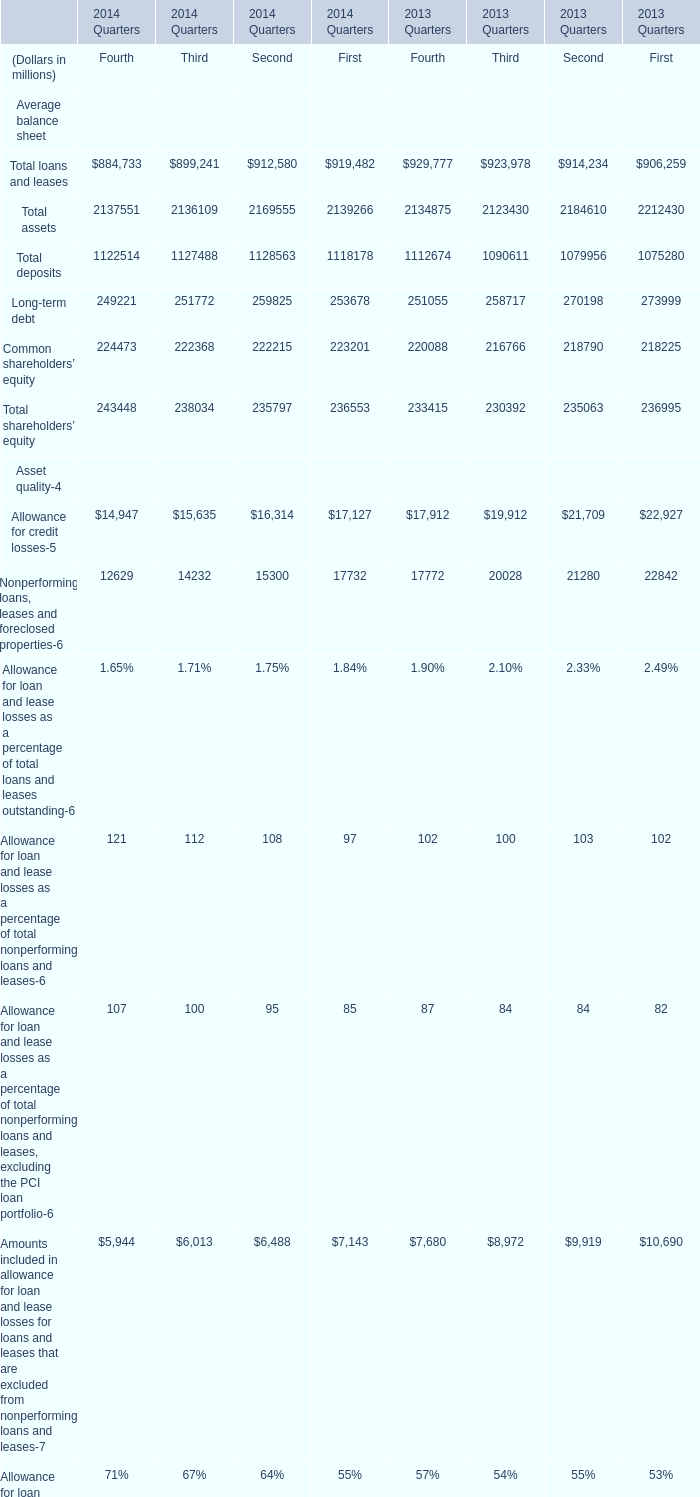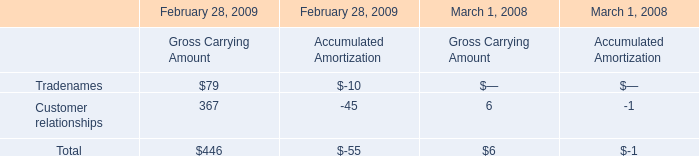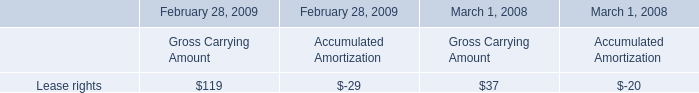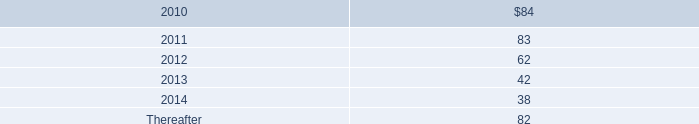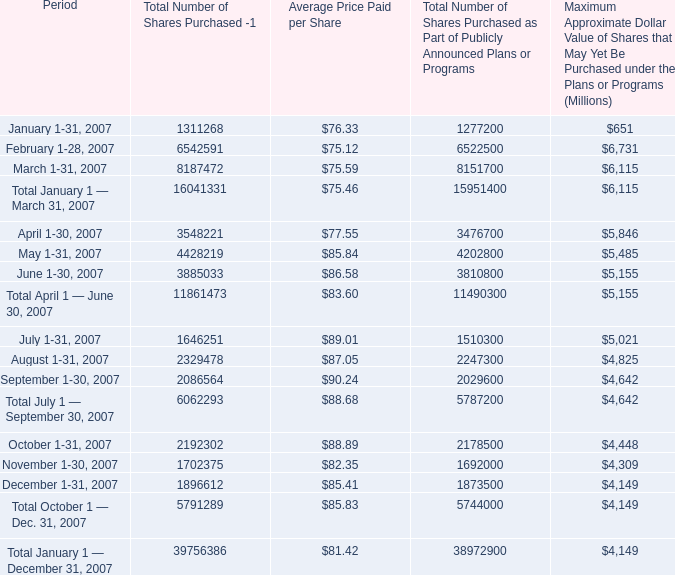What's the sum of Total assets in 2014? (in million) 
Computations: ((2137551 + 2136109) + 2169555)
Answer: 6443215.0. 